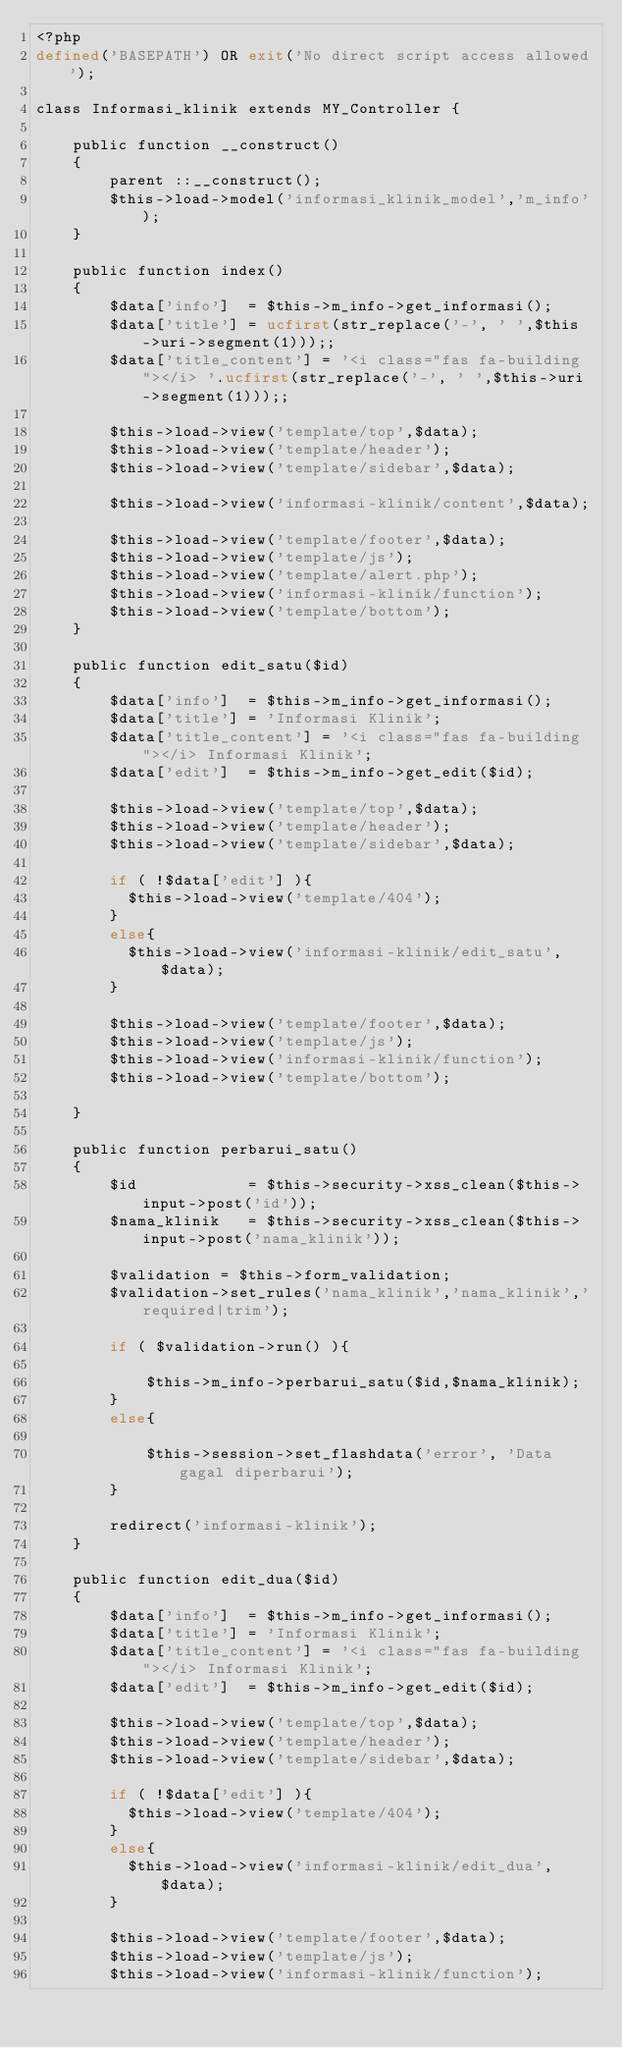Convert code to text. <code><loc_0><loc_0><loc_500><loc_500><_PHP_><?php
defined('BASEPATH') OR exit('No direct script access allowed');

class Informasi_klinik extends MY_Controller {

	public function __construct()
	{
		parent ::__construct();
		$this->load->model('informasi_klinik_model','m_info');
	}
	
	public function index()
	{
		$data['info']  = $this->m_info->get_informasi();
		$data['title'] = ucfirst(str_replace('-', ' ',$this->uri->segment(1)));;
		$data['title_content'] = '<i class="fas fa-building"></i> '.ucfirst(str_replace('-', ' ',$this->uri->segment(1)));;

		$this->load->view('template/top',$data);
		$this->load->view('template/header');
		$this->load->view('template/sidebar',$data);

		$this->load->view('informasi-klinik/content',$data);

		$this->load->view('template/footer',$data);
		$this->load->view('template/js');
		$this->load->view('template/alert.php');
		$this->load->view('informasi-klinik/function');
		$this->load->view('template/bottom');
	}

	public function edit_satu($id)
	{
		$data['info']  = $this->m_info->get_informasi();
		$data['title'] = 'Informasi Klinik';
		$data['title_content'] = '<i class="fas fa-building"></i> Informasi Klinik';
		$data['edit']  = $this->m_info->get_edit($id);

		$this->load->view('template/top',$data);
		$this->load->view('template/header');
		$this->load->view('template/sidebar',$data);

		if ( !$data['edit'] ){
		  $this->load->view('template/404');
		}
		else{
		  $this->load->view('informasi-klinik/edit_satu',$data);
		}
		
		$this->load->view('template/footer',$data);
		$this->load->view('template/js');
		$this->load->view('informasi-klinik/function');
		$this->load->view('template/bottom');

	}

	public function perbarui_satu()
	{
		$id            = $this->security->xss_clean($this->input->post('id'));
		$nama_klinik   = $this->security->xss_clean($this->input->post('nama_klinik'));

		$validation = $this->form_validation;
		$validation->set_rules('nama_klinik','nama_klinik','required|trim');

		if ( $validation->run() ){

			$this->m_info->perbarui_satu($id,$nama_klinik);
		}
		else{

			$this->session->set_flashdata('error', 'Data gagal diperbarui');
		}

		redirect('informasi-klinik');
	}

	public function edit_dua($id)
	{
		$data['info']  = $this->m_info->get_informasi();
		$data['title'] = 'Informasi Klinik';
		$data['title_content'] = '<i class="fas fa-building"></i> Informasi Klinik';
		$data['edit']  = $this->m_info->get_edit($id);

		$this->load->view('template/top',$data);
		$this->load->view('template/header');
		$this->load->view('template/sidebar',$data);

		if ( !$data['edit'] ){
		  $this->load->view('template/404');
		}
		else{
		  $this->load->view('informasi-klinik/edit_dua',$data);
		}

		$this->load->view('template/footer',$data);
		$this->load->view('template/js');
		$this->load->view('informasi-klinik/function');
		</code> 